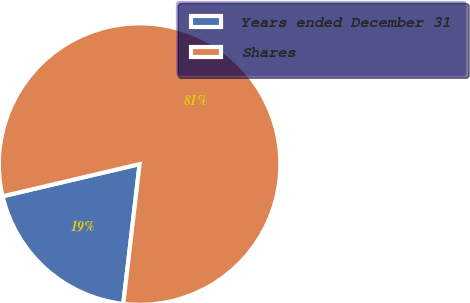Convert chart to OTSL. <chart><loc_0><loc_0><loc_500><loc_500><pie_chart><fcel>Years ended December 31<fcel>Shares<nl><fcel>19.48%<fcel>80.52%<nl></chart> 